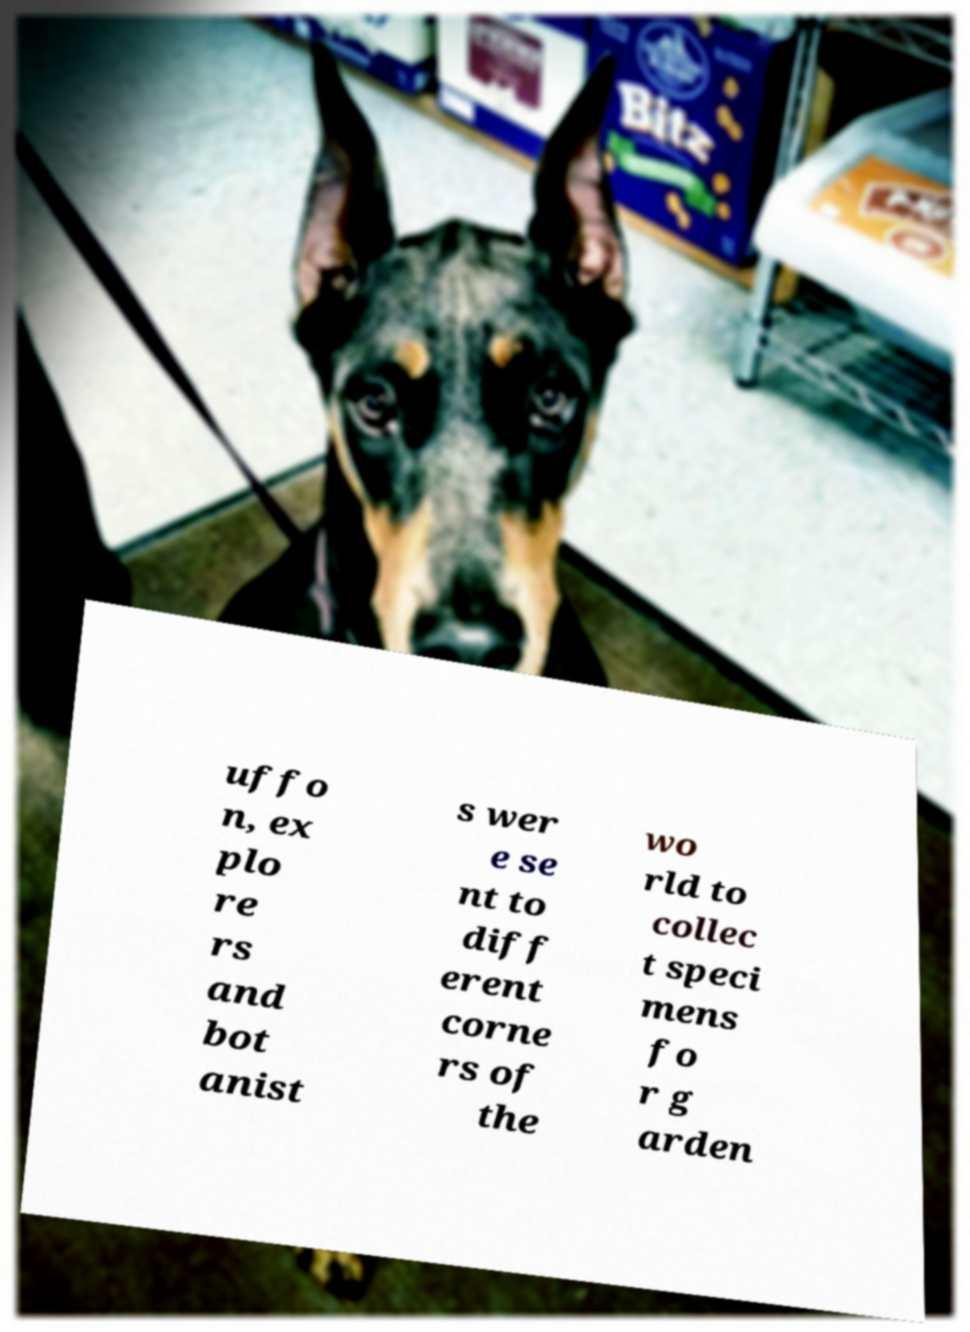Can you accurately transcribe the text from the provided image for me? uffo n, ex plo re rs and bot anist s wer e se nt to diff erent corne rs of the wo rld to collec t speci mens fo r g arden 